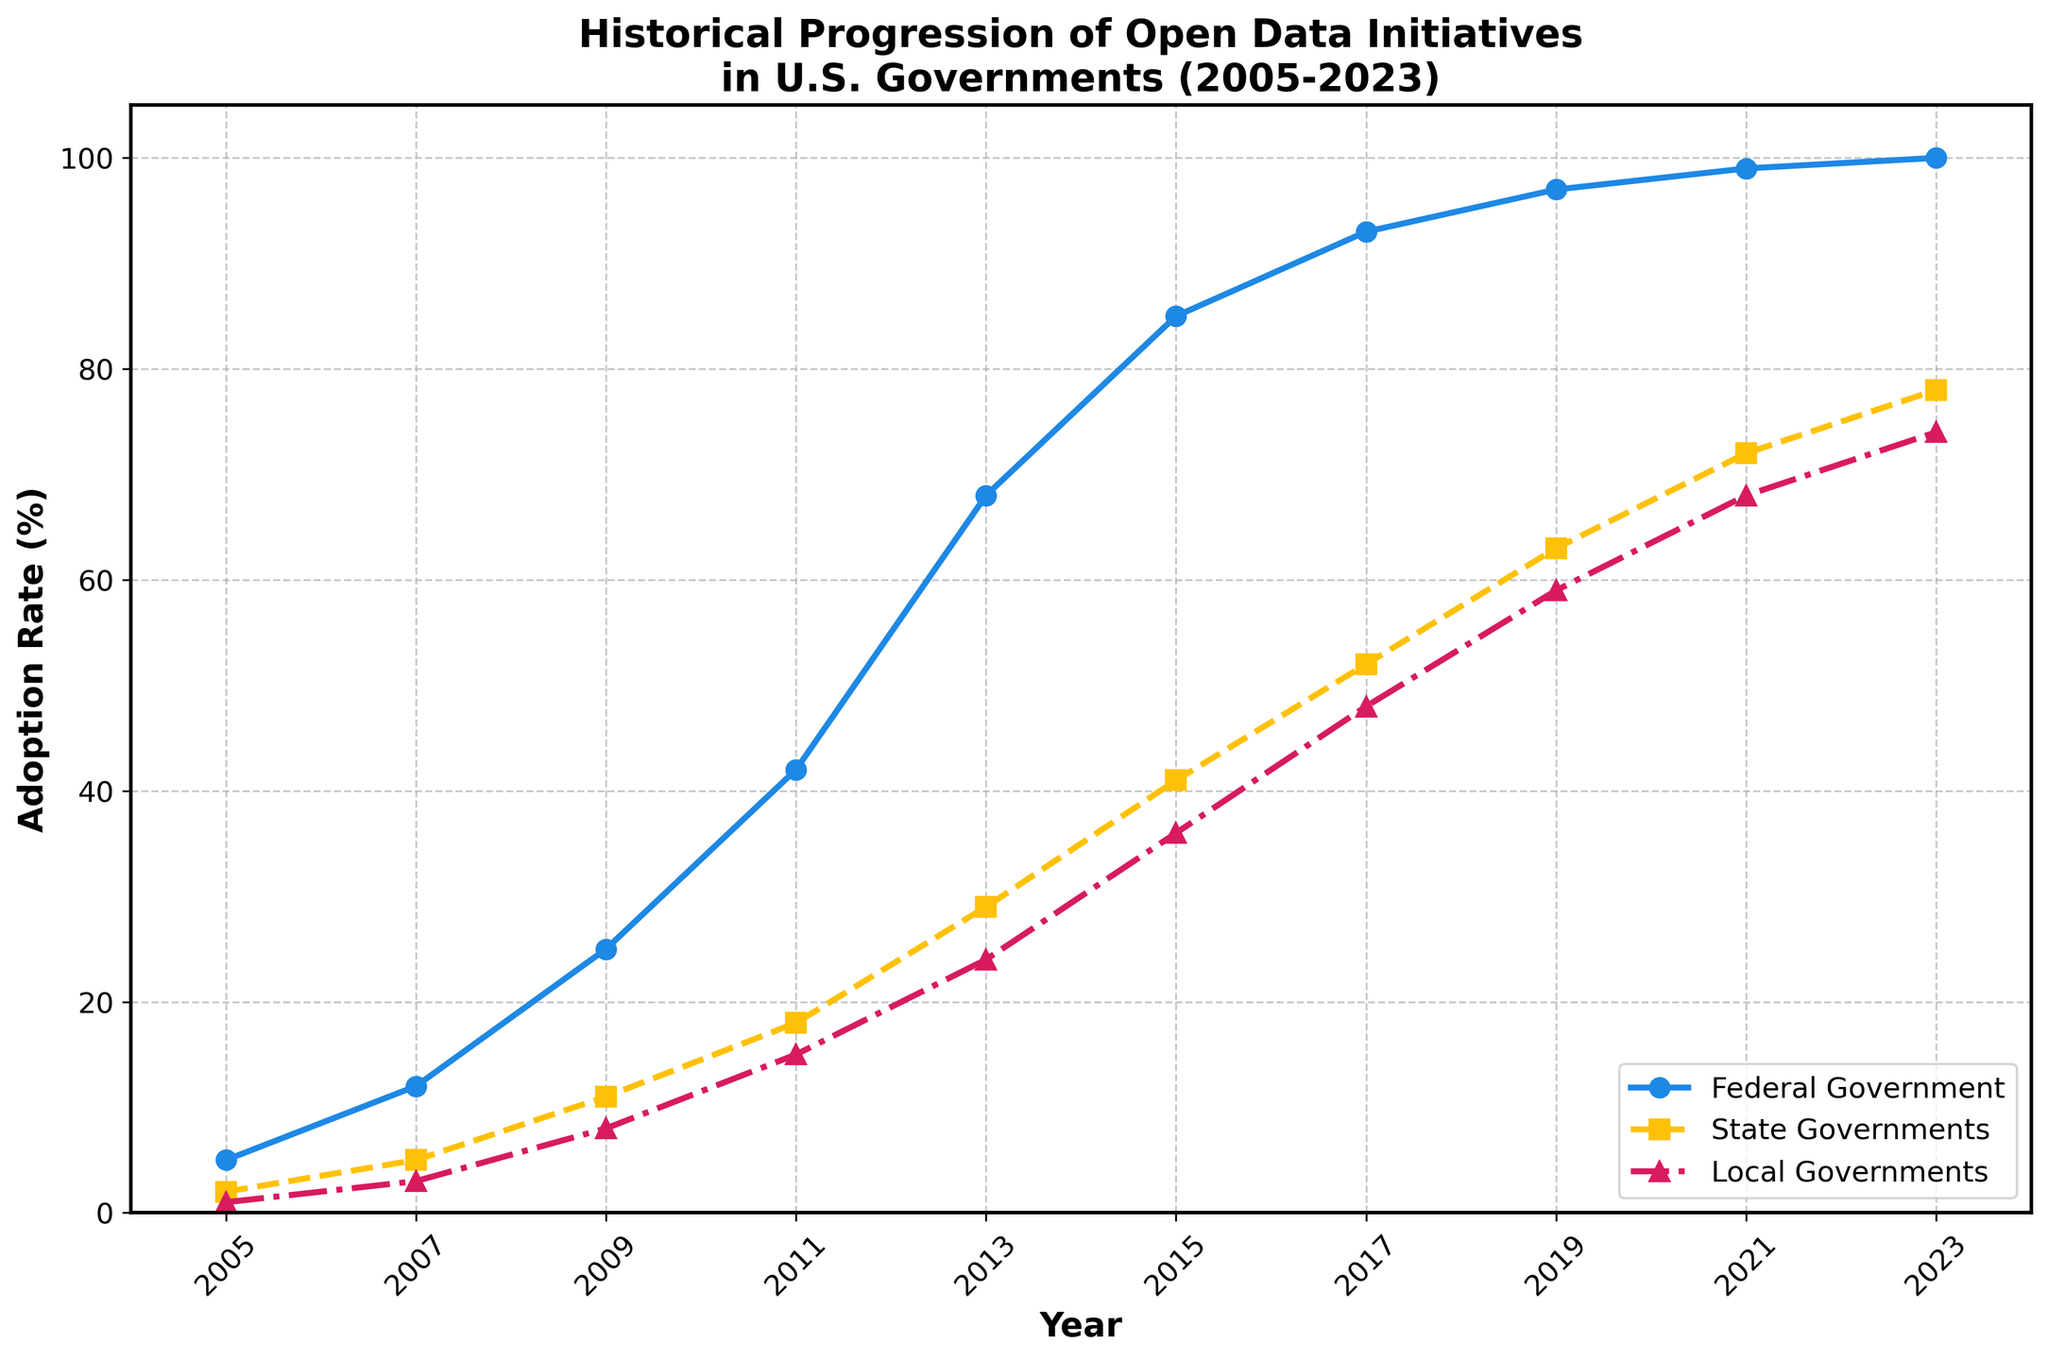What is the overall trend in the adoption of open data initiatives by the federal government from 2005 to 2023? The figure shows a consistent upward trend in the adoption of open data initiatives by the federal government from 5% in 2005 to 100% in 2023, indicating steadily increasing transparency in this period.
Answer: Increasing trend Which level of government had the highest adoption rate in 2023? By observing the endpoints of the lines in the figure for the year 2023, we can see that the federal government line reaches 100%, which is higher than the state and local governments.
Answer: Federal government By how much did the state governments' adoption rate increase between 2015 and 2019? From the figure, the adoption rate for state governments was 41% in 2015 and 63% in 2019. The increase is 63% - 41% = 22%.
Answer: 22% How do the adoption rates of local governments compare to state governments in the year 2011? In 2011, the figure shows the adoption rate for local governments at 15%, whereas for state governments it is 18%, indicating state governments had a slightly higher adoption rate.
Answer: State governments had higher adoption rates What is the difference in adoption rates between the federal and local governments in 2023? In 2023, the federal government adoption rate is 100%, and the local governments' rate is 74%. The difference is 100% - 74% = 26%.
Answer: 26% In which year did local governments first surpass an adoption rate of 50%? Referring to the line representing local governments, the adoption rate first reaches above 50% in the year 2017.
Answer: 2017 What was the average adoption rate for state governments across all years represented in the figure? Adding the adoption rates for state governments for each year from 2005 to 2023 and dividing by the number of data points (10 years): (2% + 5% + 11% + 18% + 29% + 41% + 52% + 63% + 72% + 78%) / 10 = 37.1%.
Answer: 37.1% Compare the growth rate of federal government adoption from 2005 to 2013 with that from 2013 to 2023. Which period saw faster growth? From 2005 to 2013, the adoption rate grew from 5% to 68%, an increase of 63% over 8 years (7.875% per year on average). From 2013 to 2023, it grew from 68% to 100%, an increase of 32% over 10 years (3.2% per year on average). The period from 2005 to 2013 saw faster growth.
Answer: 2005 to 2013 What visual features distinguish the lines representing federal, state, and local governments? The lines are distinguished by their style and color: the federal government line is solid blue with circle markers, the state governments line is dashed yellow with square markers, and the local governments line is dash-dot red with triangle markers.
Answer: Line style and color What is the least steep increase observed in the federal government adoption rate and in which period does it occur? The federal government's adoption rate shows the least steep increase in the period from 2013 to 2023, where the rate increases from 68% to 100%, a more gradual rise compared to earlier periods.
Answer: 2013 to 2023 